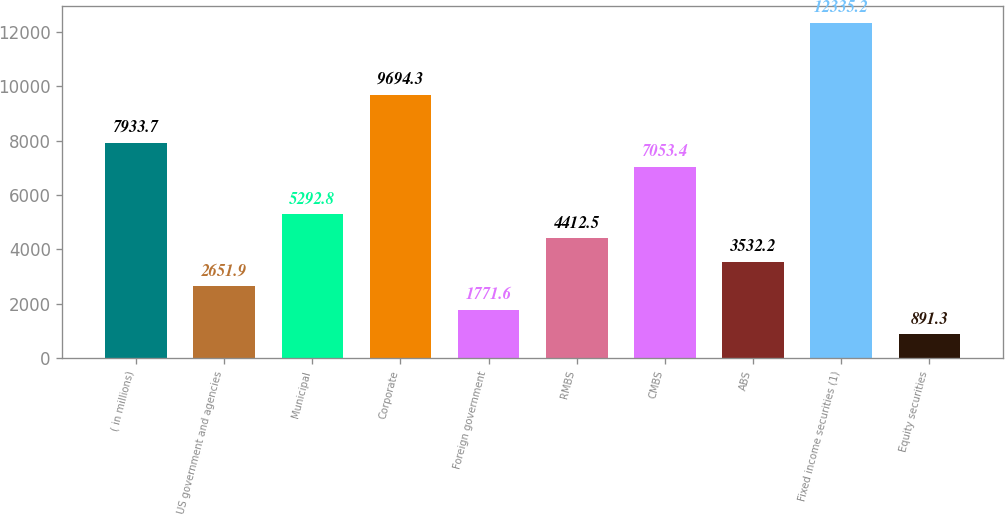Convert chart to OTSL. <chart><loc_0><loc_0><loc_500><loc_500><bar_chart><fcel>( in millions)<fcel>US government and agencies<fcel>Municipal<fcel>Corporate<fcel>Foreign government<fcel>RMBS<fcel>CMBS<fcel>ABS<fcel>Fixed income securities (1)<fcel>Equity securities<nl><fcel>7933.7<fcel>2651.9<fcel>5292.8<fcel>9694.3<fcel>1771.6<fcel>4412.5<fcel>7053.4<fcel>3532.2<fcel>12335.2<fcel>891.3<nl></chart> 